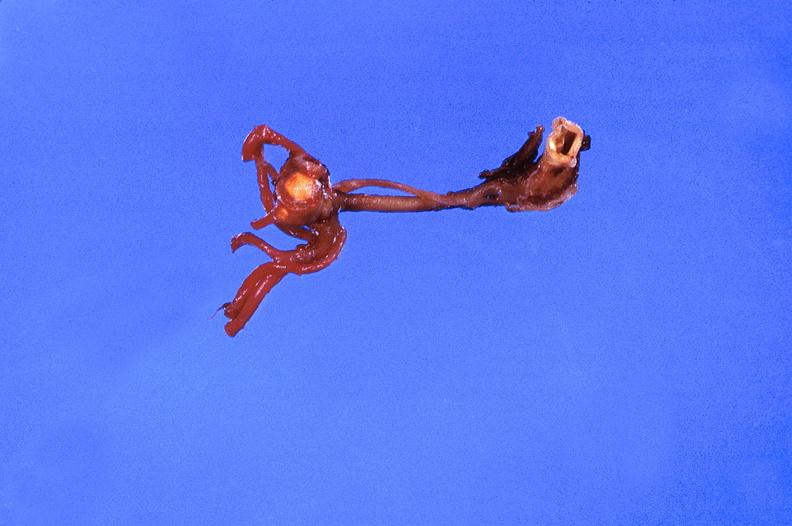what does this image show?
Answer the question using a single word or phrase. Ruptured saccular aneurysm right middle cerebral artery 